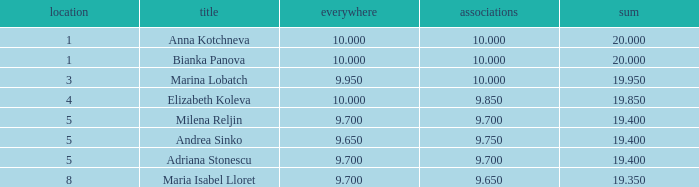What total has 10 as the clubs, with a place greater than 1? 19.95. 